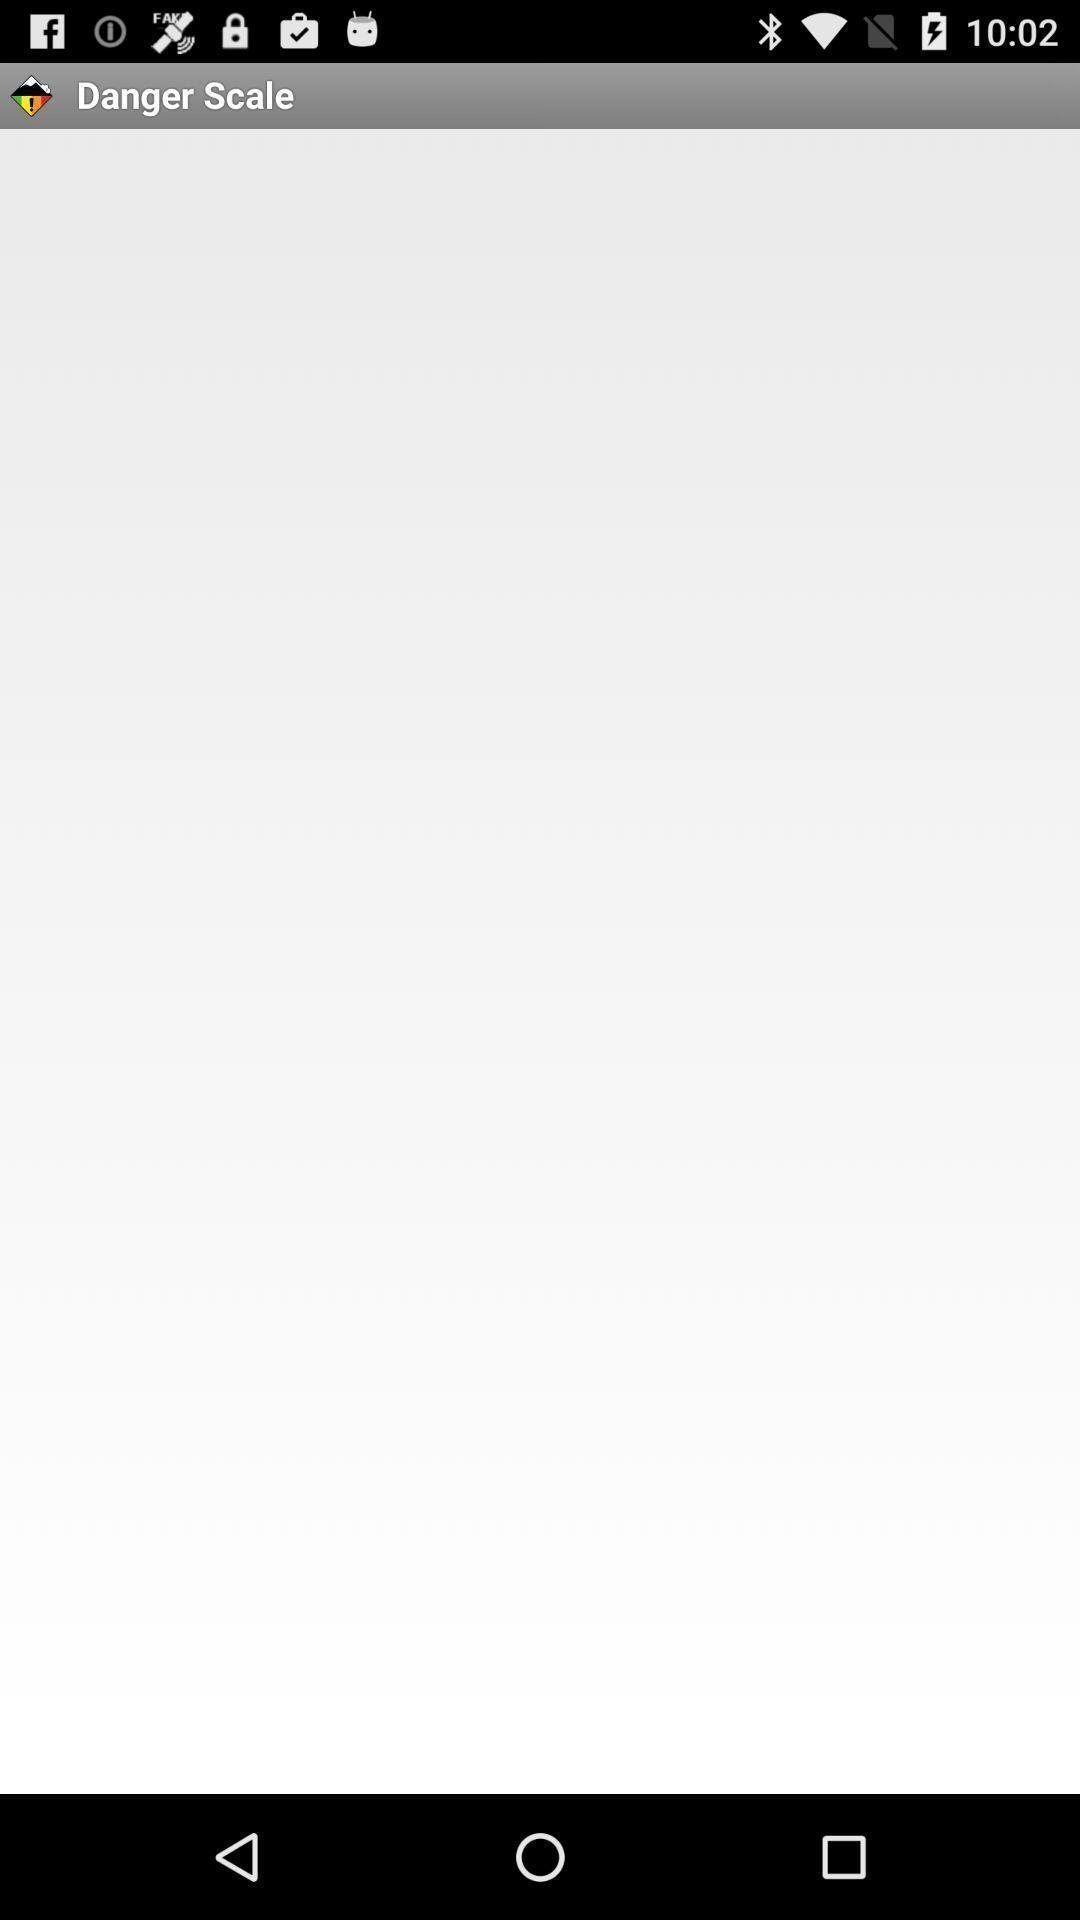Give me a summary of this screen capture. Page displaying the loading. 